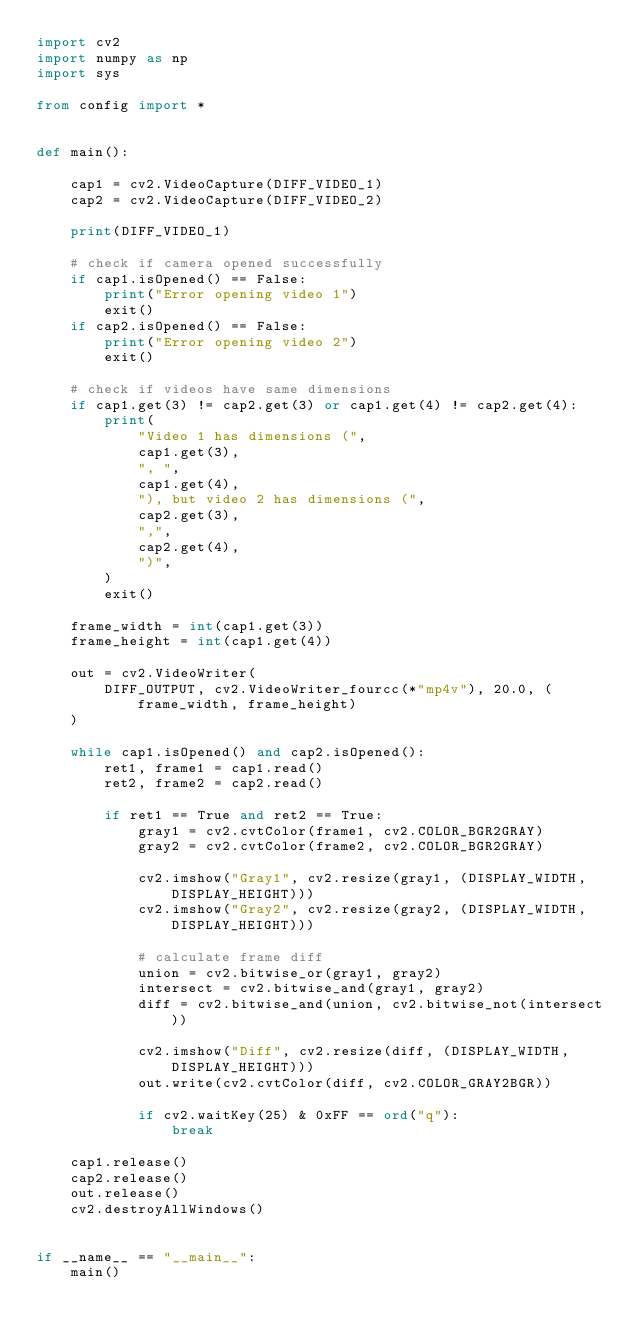Convert code to text. <code><loc_0><loc_0><loc_500><loc_500><_Python_>import cv2
import numpy as np
import sys

from config import *


def main():

    cap1 = cv2.VideoCapture(DIFF_VIDEO_1)
    cap2 = cv2.VideoCapture(DIFF_VIDEO_2)

    print(DIFF_VIDEO_1)

    # check if camera opened successfully
    if cap1.isOpened() == False:
        print("Error opening video 1")
        exit()
    if cap2.isOpened() == False:
        print("Error opening video 2")
        exit()

    # check if videos have same dimensions
    if cap1.get(3) != cap2.get(3) or cap1.get(4) != cap2.get(4):
        print(
            "Video 1 has dimensions (",
            cap1.get(3),
            ", ",
            cap1.get(4),
            "), but video 2 has dimensions (",
            cap2.get(3),
            ",",
            cap2.get(4),
            ")",
        )
        exit()

    frame_width = int(cap1.get(3))
    frame_height = int(cap1.get(4))

    out = cv2.VideoWriter(
        DIFF_OUTPUT, cv2.VideoWriter_fourcc(*"mp4v"), 20.0, (frame_width, frame_height)
    )

    while cap1.isOpened() and cap2.isOpened():
        ret1, frame1 = cap1.read()
        ret2, frame2 = cap2.read()

        if ret1 == True and ret2 == True:
            gray1 = cv2.cvtColor(frame1, cv2.COLOR_BGR2GRAY)
            gray2 = cv2.cvtColor(frame2, cv2.COLOR_BGR2GRAY)

            cv2.imshow("Gray1", cv2.resize(gray1, (DISPLAY_WIDTH, DISPLAY_HEIGHT)))
            cv2.imshow("Gray2", cv2.resize(gray2, (DISPLAY_WIDTH, DISPLAY_HEIGHT)))

            # calculate frame diff
            union = cv2.bitwise_or(gray1, gray2)
            intersect = cv2.bitwise_and(gray1, gray2)
            diff = cv2.bitwise_and(union, cv2.bitwise_not(intersect))

            cv2.imshow("Diff", cv2.resize(diff, (DISPLAY_WIDTH, DISPLAY_HEIGHT)))
            out.write(cv2.cvtColor(diff, cv2.COLOR_GRAY2BGR))

            if cv2.waitKey(25) & 0xFF == ord("q"):
                break

    cap1.release()
    cap2.release()
    out.release()
    cv2.destroyAllWindows()


if __name__ == "__main__":
    main()
</code> 